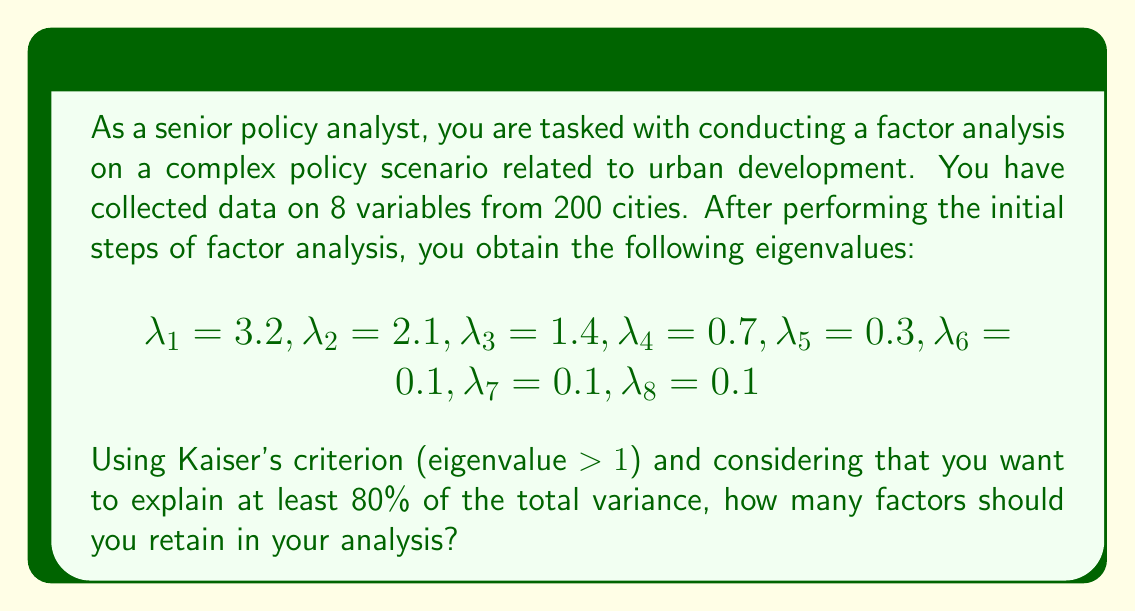Show me your answer to this math problem. To solve this problem, we need to follow these steps:

1. Calculate the total variance:
   $$\text{Total Variance} = \sum_{i=1}^8 \lambda_i = 3.2 + 2.1 + 1.4 + 0.7 + 0.3 + 0.1 + 0.1 + 0.1 = 8$$

2. Apply Kaiser's criterion:
   Factors with eigenvalues greater than 1 are: $\lambda_1, \lambda_2, \lambda_3$

3. Calculate the cumulative variance explained by these factors:
   $$\text{Variance Explained} = \frac{3.2 + 2.1 + 1.4}{8} \times 100\% = \frac{6.7}{8} \times 100\% = 83.75\%$$

4. Check if this meets the 80% threshold:
   83.75% > 80%, so this criterion is satisfied.

5. Confirm the number of factors:
   The first three factors ($\lambda_1, \lambda_2, \lambda_3$) satisfy both Kaiser's criterion and the 80% variance explained threshold.

Therefore, you should retain 3 factors in your analysis.
Answer: 3 factors 